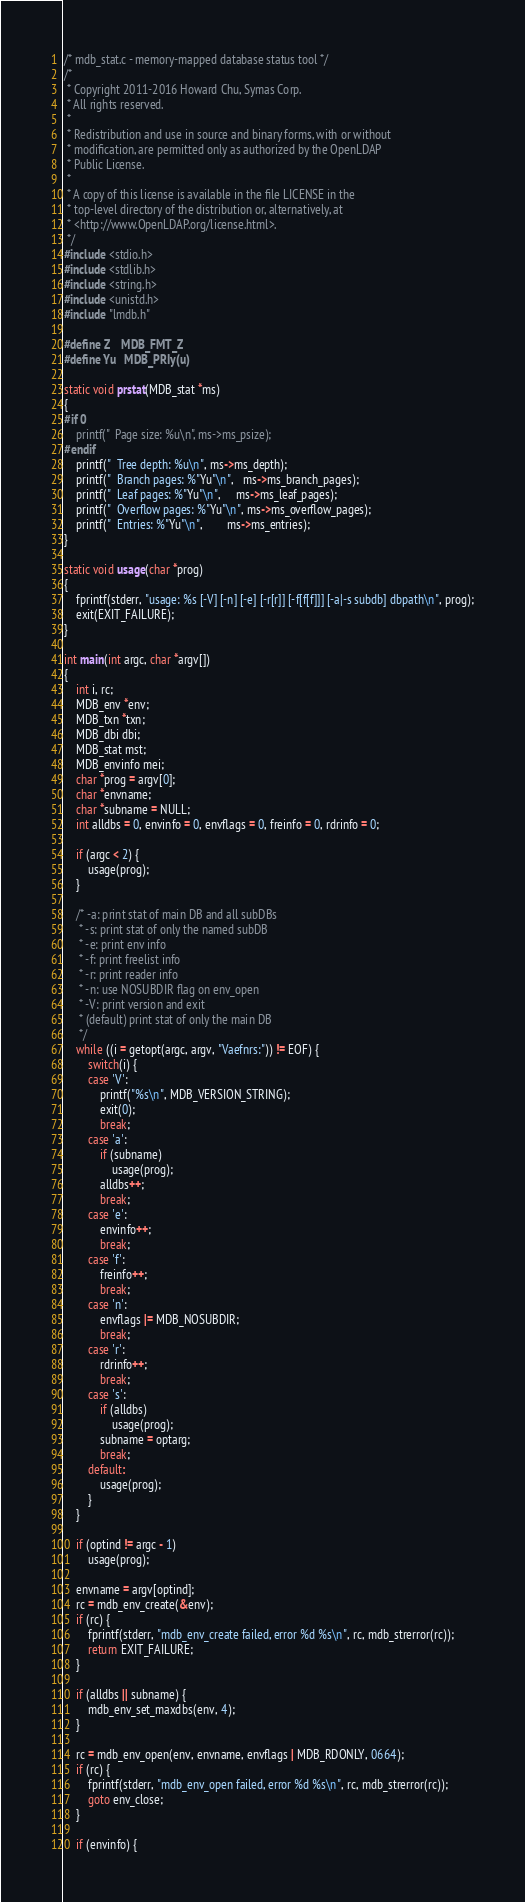Convert code to text. <code><loc_0><loc_0><loc_500><loc_500><_C_>/* mdb_stat.c - memory-mapped database status tool */
/*
 * Copyright 2011-2016 Howard Chu, Symas Corp.
 * All rights reserved.
 *
 * Redistribution and use in source and binary forms, with or without
 * modification, are permitted only as authorized by the OpenLDAP
 * Public License.
 *
 * A copy of this license is available in the file LICENSE in the
 * top-level directory of the distribution or, alternatively, at
 * <http://www.OpenLDAP.org/license.html>.
 */
#include <stdio.h>
#include <stdlib.h>
#include <string.h>
#include <unistd.h>
#include "lmdb.h"

#define Z	MDB_FMT_Z
#define Yu	MDB_PRIy(u)

static void prstat(MDB_stat *ms)
{
#if 0
	printf("  Page size: %u\n", ms->ms_psize);
#endif
	printf("  Tree depth: %u\n", ms->ms_depth);
	printf("  Branch pages: %"Yu"\n",   ms->ms_branch_pages);
	printf("  Leaf pages: %"Yu"\n",     ms->ms_leaf_pages);
	printf("  Overflow pages: %"Yu"\n", ms->ms_overflow_pages);
	printf("  Entries: %"Yu"\n",        ms->ms_entries);
}

static void usage(char *prog)
{
	fprintf(stderr, "usage: %s [-V] [-n] [-e] [-r[r]] [-f[f[f]]] [-a|-s subdb] dbpath\n", prog);
	exit(EXIT_FAILURE);
}

int main(int argc, char *argv[])
{
	int i, rc;
	MDB_env *env;
	MDB_txn *txn;
	MDB_dbi dbi;
	MDB_stat mst;
	MDB_envinfo mei;
	char *prog = argv[0];
	char *envname;
	char *subname = NULL;
	int alldbs = 0, envinfo = 0, envflags = 0, freinfo = 0, rdrinfo = 0;

	if (argc < 2) {
		usage(prog);
	}

	/* -a: print stat of main DB and all subDBs
	 * -s: print stat of only the named subDB
	 * -e: print env info
	 * -f: print freelist info
	 * -r: print reader info
	 * -n: use NOSUBDIR flag on env_open
	 * -V: print version and exit
	 * (default) print stat of only the main DB
	 */
	while ((i = getopt(argc, argv, "Vaefnrs:")) != EOF) {
		switch(i) {
		case 'V':
			printf("%s\n", MDB_VERSION_STRING);
			exit(0);
			break;
		case 'a':
			if (subname)
				usage(prog);
			alldbs++;
			break;
		case 'e':
			envinfo++;
			break;
		case 'f':
			freinfo++;
			break;
		case 'n':
			envflags |= MDB_NOSUBDIR;
			break;
		case 'r':
			rdrinfo++;
			break;
		case 's':
			if (alldbs)
				usage(prog);
			subname = optarg;
			break;
		default:
			usage(prog);
		}
	}

	if (optind != argc - 1)
		usage(prog);

	envname = argv[optind];
	rc = mdb_env_create(&env);
	if (rc) {
		fprintf(stderr, "mdb_env_create failed, error %d %s\n", rc, mdb_strerror(rc));
		return EXIT_FAILURE;
	}

	if (alldbs || subname) {
		mdb_env_set_maxdbs(env, 4);
	}

	rc = mdb_env_open(env, envname, envflags | MDB_RDONLY, 0664);
	if (rc) {
		fprintf(stderr, "mdb_env_open failed, error %d %s\n", rc, mdb_strerror(rc));
		goto env_close;
	}

	if (envinfo) {</code> 